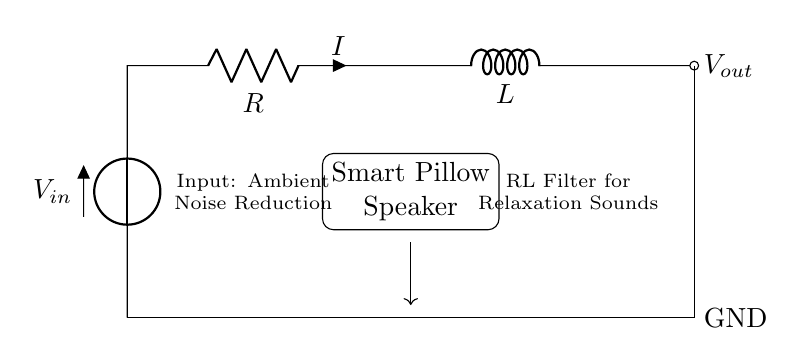What type of filter is this circuit? The circuit is an RL filter, which consists of a resistor and an inductor. The "RL" indicates the combination of these two components.
Answer: RL filter What is the purpose of the smart pillow speaker? The smart pillow speaker is designed to deliver relaxation sounds, helping reduce ambient noise and facilitate better sleep.
Answer: Relaxation sounds What component is represented by "R"? "R" represents the resistor, which is used in the circuit to control the current flow and help in filtering the signal.
Answer: Resistor What is the output of the RL filter? The output is specified as "Vout", indicating the voltage signal that results from the filtering action of the circuit.
Answer: Vout How does the inductor affect the circuit? The inductor "L" introduces inductive reactance, which helps smooth out fluctuations in current over time, allowing for better sound quality for the relaxation sounds.
Answer: Smooths current What is the significance of "Vin" in the circuit? "Vin" represents the input voltage to the circuit, which provides the initial power needed for the operation of the RL filter and the speaker.
Answer: Input voltage What type of noise reduction does this circuit aim for? The circuit aims for ambient noise reduction, meaning it focuses on minimizing disruptive background sounds to promote a restful environment.
Answer: Ambient noise reduction 